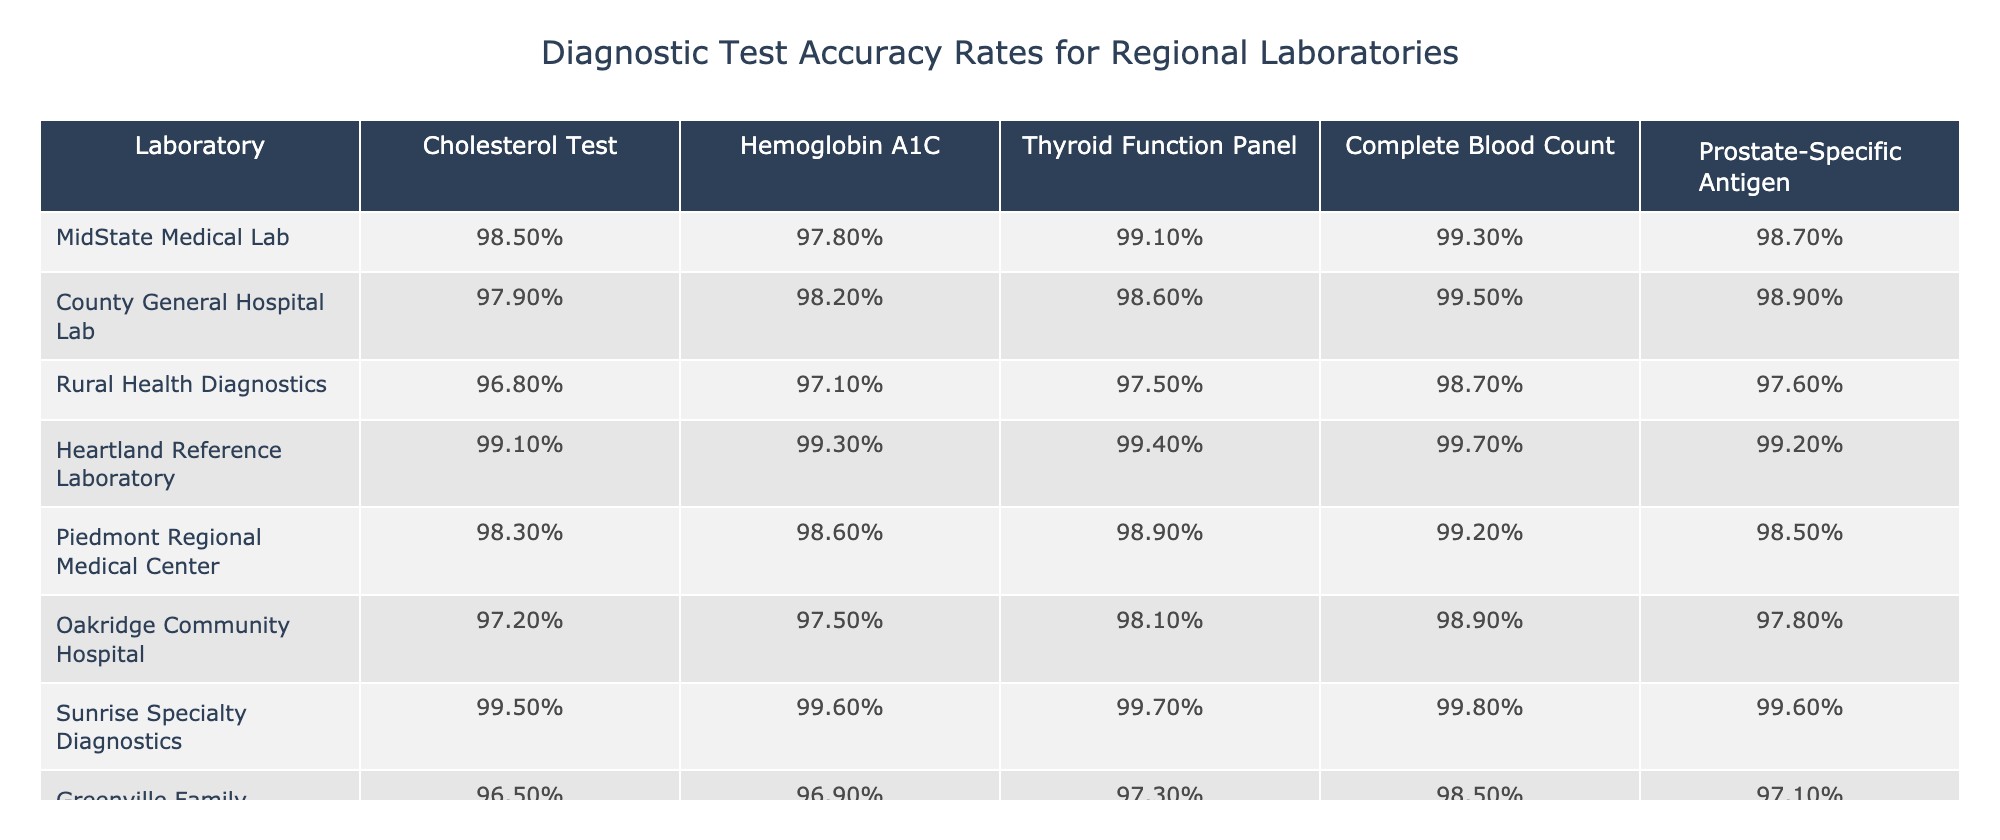What's the accuracy rate for Hemoglobin A1C at Heartland Reference Laboratory? The Hemoglobin A1C accuracy rate at Heartland Reference Laboratory is listed in the corresponding row, which shows a value of 99.3%.
Answer: 99.3% Which laboratory has the highest accuracy rate for the Thyroid Function Panel? By comparing the accuracy rates for the Thyroid Function Panel across all laboratories, Heartland Reference Laboratory has the highest accuracy rate at 99.4%.
Answer: Heartland Reference Laboratory What is the average accuracy rate for the Complete Blood Count tests across all laboratories? The accuracy rates are 99.3%, 99.5%, 98.7%, 99.7%, 99.2%, 98.9%, 99.8%, and 98.5%. Adding these yields 794.6%, then dividing by 8 gives an average of 99.325%.
Answer: 99.33% Do any laboratories have an accuracy rate for Prostate-Specific Antigen below 98%? Upon reviewing the Prostate-Specific Antigen accuracy rates, both Rural Health Diagnostics (97.6%) and Greenville Family Practice Lab (97.1%) have rates below 98%.
Answer: Yes Which laboratory has the lowest accuracy rate for the Cholesterol Test? The accuracy rates for the Cholesterol Test are 98.5%, 97.9%, 96.8%, 99.1%, 98.3%, 97.2%, 99.5%, and 96.5%. The lowest value is from Rural Health Diagnostics at 96.8%.
Answer: Rural Health Diagnostics What is the difference between the highest and lowest accuracy rates for the Complete Blood Count tests? The highest accuracy rate for the Complete Blood Count is 99.7% from Heartland Reference Laboratory, and the lowest is 98.5% from Greenville Family Practice Lab. The difference is 99.7% - 98.5% = 1.2%.
Answer: 1.2% If I wanted to refer a patient based on the best accuracy for Thyroid Function Panel, which lab would I choose? Heartland Reference Laboratory has the highest accuracy rate for the Thyroid Function Panel at 99.4%, making it the best choice for referral.
Answer: Heartland Reference Laboratory What is the overall trend in test accuracy rates between MidState Medical Lab and County General Hospital Lab for Hemoglobin A1C? MidState Medical Lab has an accuracy rate of 97.8% for Hemoglobin A1C while County General Hospital Lab has 98.2%. Comparing the two, County General Hospital Lab shows a slightly higher accuracy by 0.4%.
Answer: County General Hospital Lab is slightly higher Which lab offers the highest overall accuracy across all tests combined? To determine the overall accuracy, we'd sum the rates for each lab: MidState Medical Lab (98.5% + 97.8% + 99.1% + 99.3% + 98.7% = 493.4%) and repeat this for each lab. Upon calculation, the lab with the highest total would be Heartland Reference Laboratory.
Answer: Heartland Reference Laboratory Is the accuracy of thyroid tests in Rural Health Diagnostics above average when compared to others? The average accuracy for the Thyroid Function Panel is 98.9%. Rural Health Diagnostics shows an accuracy of 97.5%, which is below the average.
Answer: No 